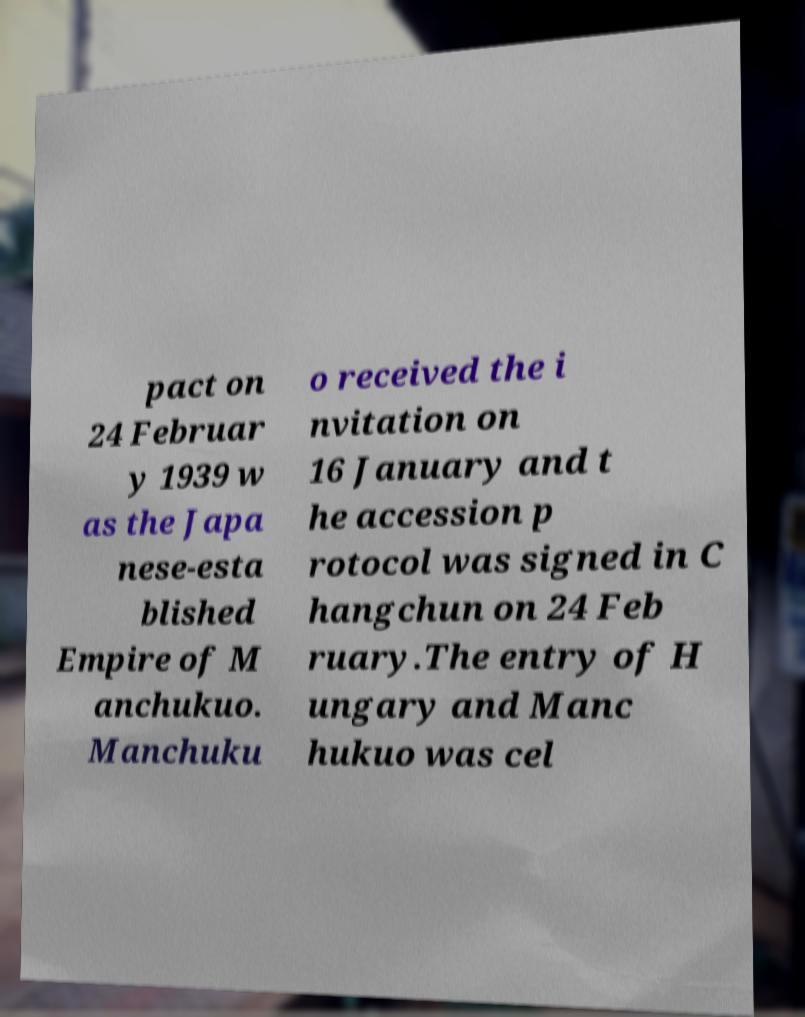What messages or text are displayed in this image? I need them in a readable, typed format. pact on 24 Februar y 1939 w as the Japa nese-esta blished Empire of M anchukuo. Manchuku o received the i nvitation on 16 January and t he accession p rotocol was signed in C hangchun on 24 Feb ruary.The entry of H ungary and Manc hukuo was cel 